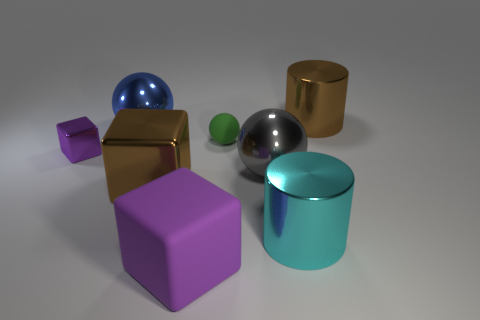Subtract all green rubber spheres. How many spheres are left? 2 Subtract all gray spheres. How many purple cubes are left? 2 Add 2 tiny red balls. How many objects exist? 10 Subtract 1 blocks. How many blocks are left? 2 Subtract all blocks. How many objects are left? 5 Subtract all large red metallic balls. Subtract all cyan objects. How many objects are left? 7 Add 1 large cylinders. How many large cylinders are left? 3 Add 1 large purple spheres. How many large purple spheres exist? 1 Subtract 0 yellow blocks. How many objects are left? 8 Subtract all yellow balls. Subtract all gray cylinders. How many balls are left? 3 